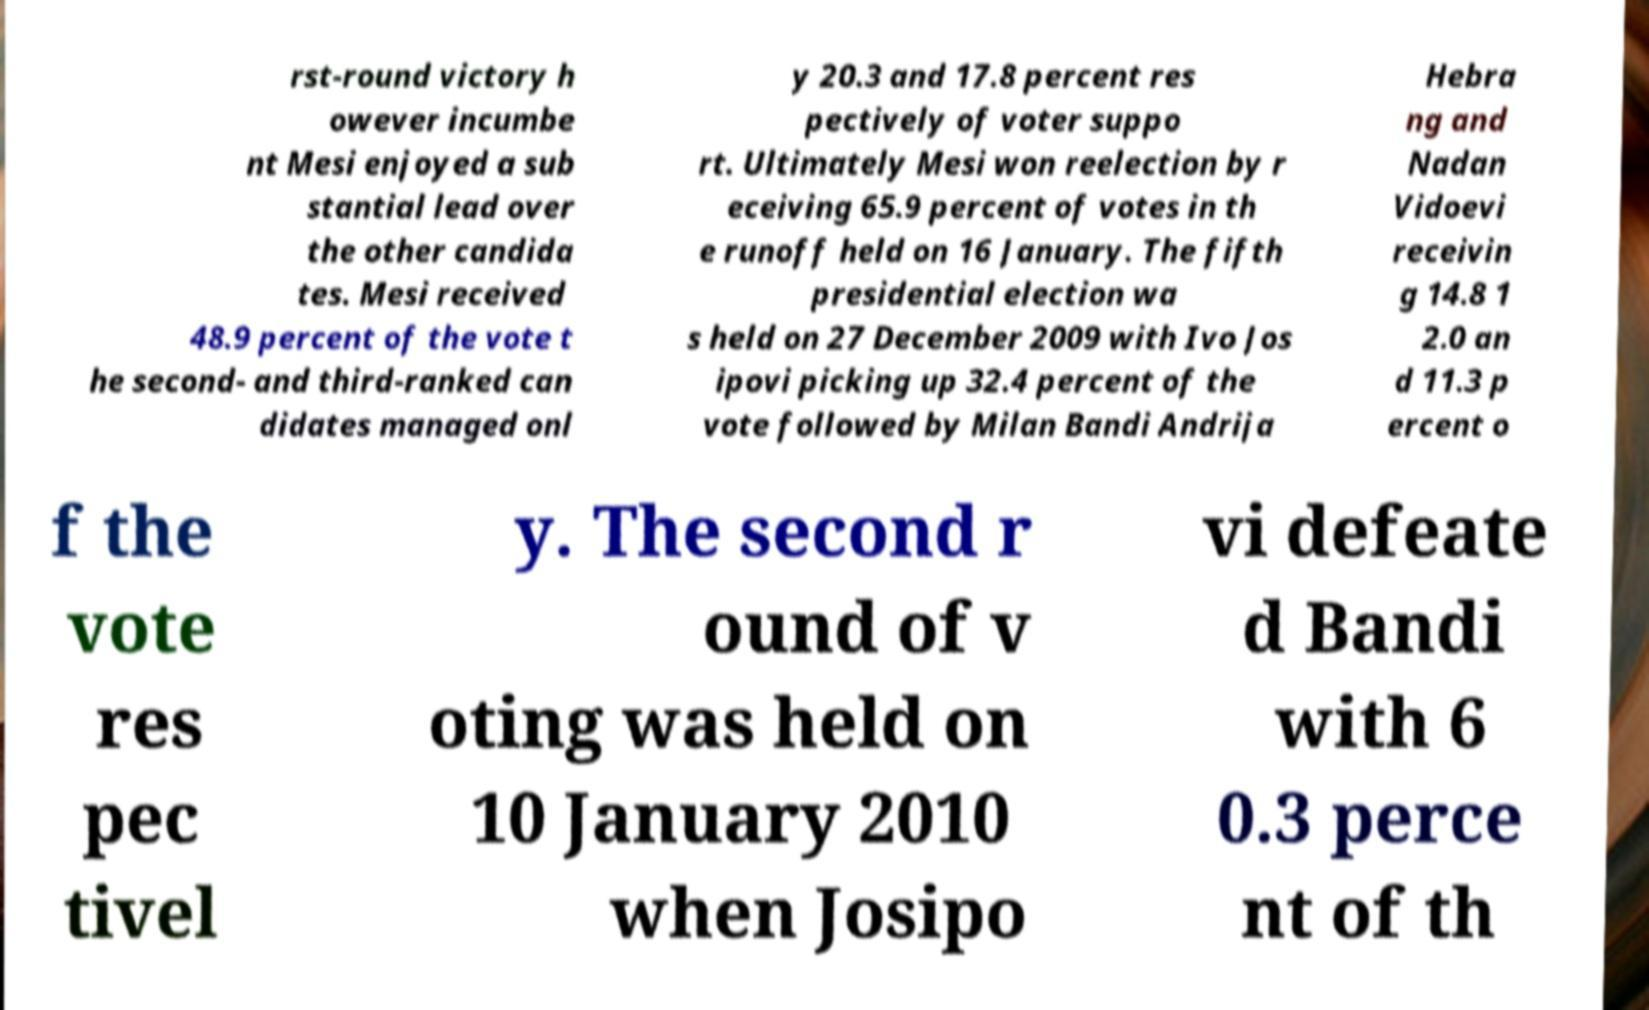Please read and relay the text visible in this image. What does it say? rst-round victory h owever incumbe nt Mesi enjoyed a sub stantial lead over the other candida tes. Mesi received 48.9 percent of the vote t he second- and third-ranked can didates managed onl y 20.3 and 17.8 percent res pectively of voter suppo rt. Ultimately Mesi won reelection by r eceiving 65.9 percent of votes in th e runoff held on 16 January. The fifth presidential election wa s held on 27 December 2009 with Ivo Jos ipovi picking up 32.4 percent of the vote followed by Milan Bandi Andrija Hebra ng and Nadan Vidoevi receivin g 14.8 1 2.0 an d 11.3 p ercent o f the vote res pec tivel y. The second r ound of v oting was held on 10 January 2010 when Josipo vi defeate d Bandi with 6 0.3 perce nt of th 